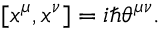Convert formula to latex. <formula><loc_0><loc_0><loc_500><loc_500>[ x ^ { \mu } , x ^ { \nu } ] = i \hbar { \theta } ^ { \mu \nu } .</formula> 